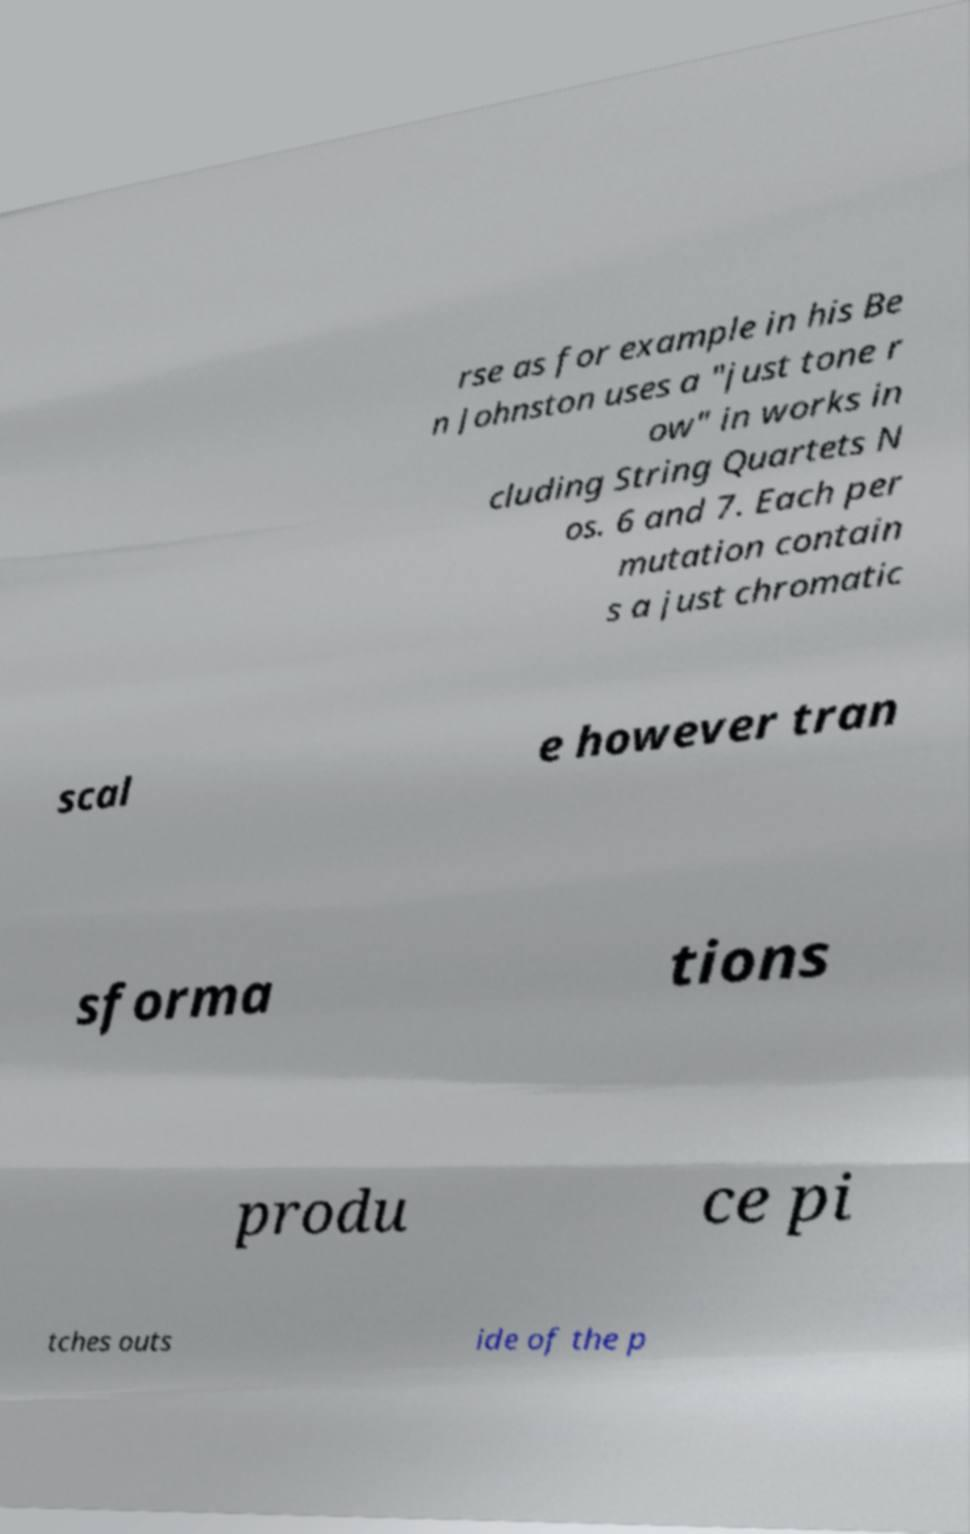Can you accurately transcribe the text from the provided image for me? rse as for example in his Be n Johnston uses a "just tone r ow" in works in cluding String Quartets N os. 6 and 7. Each per mutation contain s a just chromatic scal e however tran sforma tions produ ce pi tches outs ide of the p 